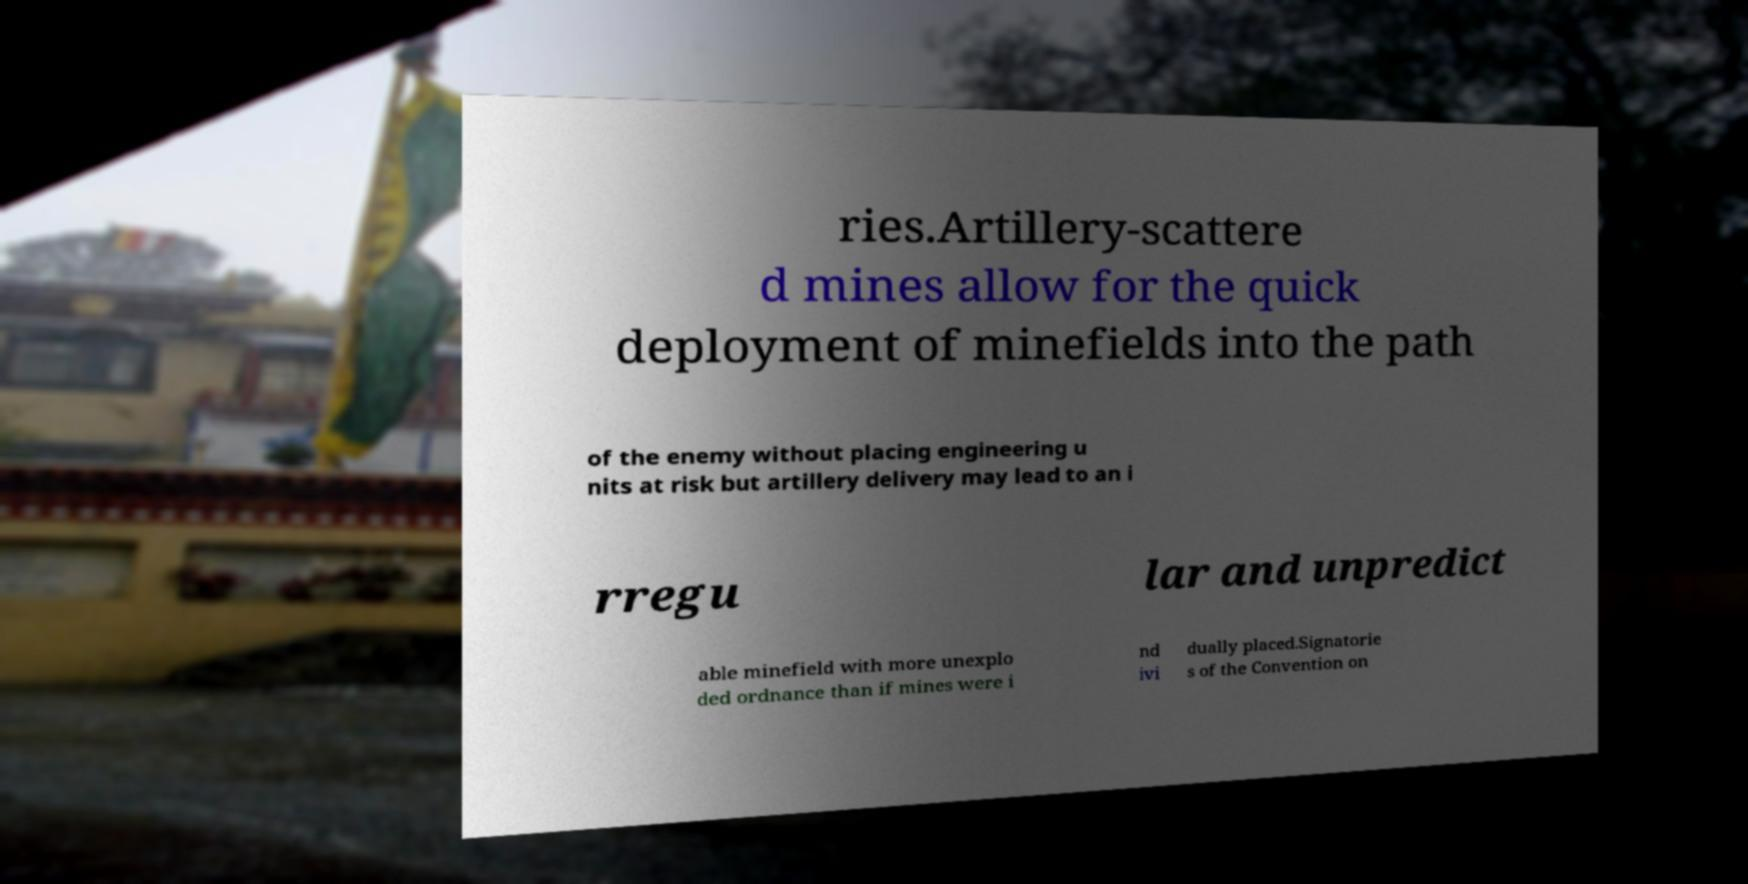Could you extract and type out the text from this image? ries.Artillery-scattere d mines allow for the quick deployment of minefields into the path of the enemy without placing engineering u nits at risk but artillery delivery may lead to an i rregu lar and unpredict able minefield with more unexplo ded ordnance than if mines were i nd ivi dually placed.Signatorie s of the Convention on 